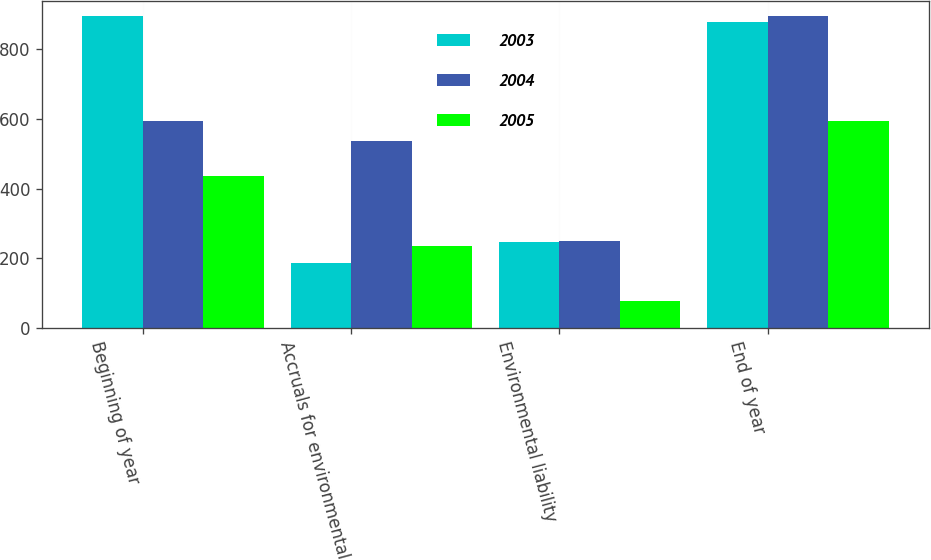Convert chart. <chart><loc_0><loc_0><loc_500><loc_500><stacked_bar_chart><ecel><fcel>Beginning of year<fcel>Accruals for environmental<fcel>Environmental liability<fcel>End of year<nl><fcel>2003<fcel>895<fcel>186<fcel>247<fcel>879<nl><fcel>2004<fcel>593<fcel>536<fcel>248<fcel>895<nl><fcel>2005<fcel>435<fcel>235<fcel>77<fcel>593<nl></chart> 